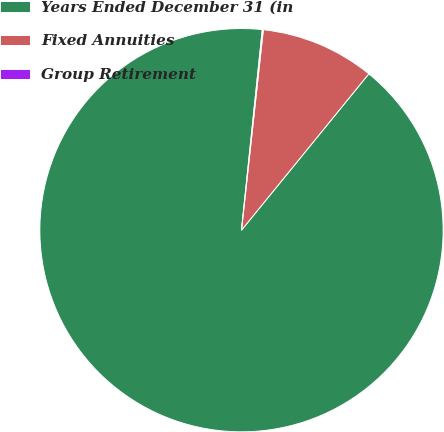Convert chart. <chart><loc_0><loc_0><loc_500><loc_500><pie_chart><fcel>Years Ended December 31 (in<fcel>Fixed Annuities<fcel>Group Retirement<nl><fcel>90.76%<fcel>9.15%<fcel>0.08%<nl></chart> 